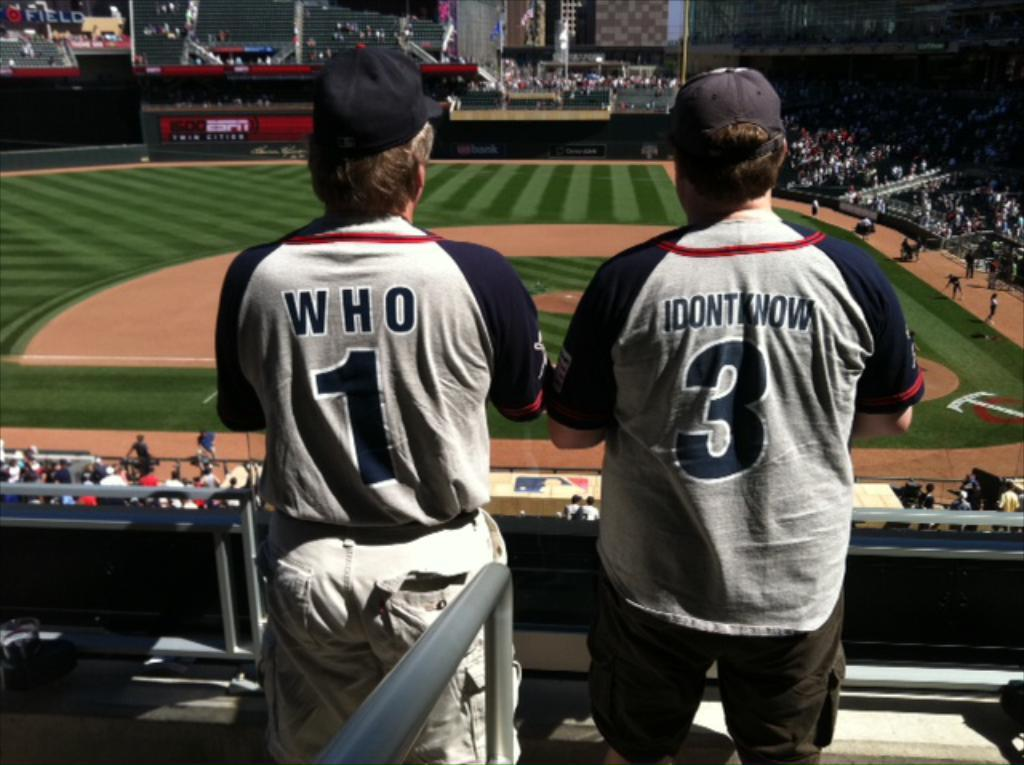<image>
Give a short and clear explanation of the subsequent image. Two sports players with the numbers 1 and 3 on their shirts respectively. 